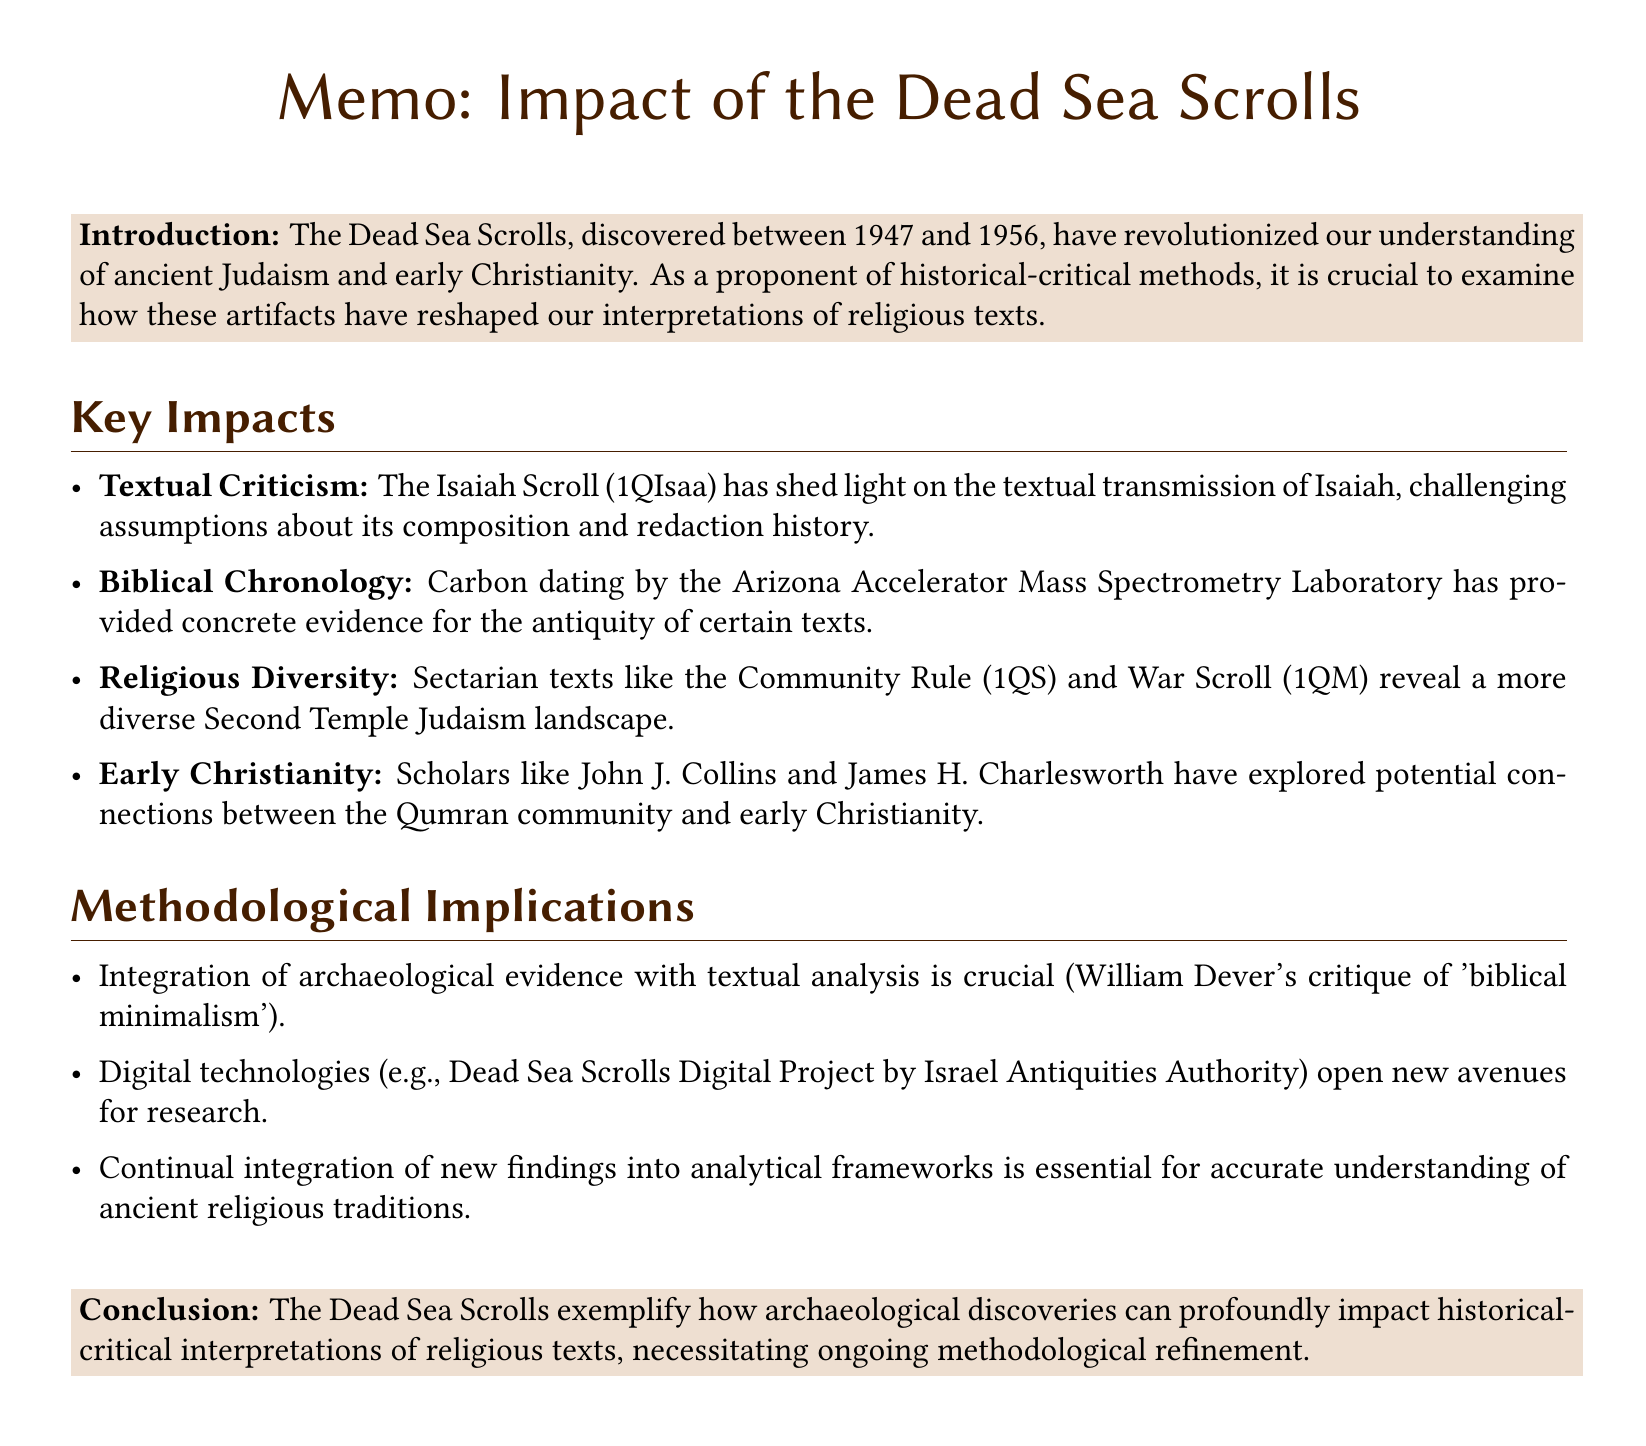What year were the Dead Sea Scrolls discovered? The document states that the Dead Sea Scrolls were discovered between 1947 and 1956.
Answer: 1947-1956 Which scroll is specifically mentioned as shedding light on the textual transmission of Isaiah? The document mentions the Isaiah Scroll (1QIsaa) in relation to textual criticism.
Answer: Isaiah Scroll (1QIsaa) Who are two scholars that have explored connections between the Qumran community and early Christianity? The memo lists John J. Collins and James H. Charlesworth as key figures in this area of research.
Answer: John J. Collins and James H. Charlesworth What archaeological technique was used to date the Dead Sea Scrolls? The document mentions carbon dating, specifically conducted by the Arizona Accelerator Mass Spectrometry Laboratory.
Answer: Carbon dating What title is given to the sectarian text that discusses community rules? The document identifies the Community Rule (1QS) as a sectarian text.
Answer: Community Rule (1QS) What major implication of the Dead Sea Scrolls is highlighted regarding methodologies in religious studies? The memo notes that integration of archaeological evidence with textual analysis is crucial.
Answer: Integration of archaeological evidence with textual analysis What is the name of the digital project associated with the Dead Sea Scrolls for research? The document refers to the Dead Sea Scrolls Digital Project by the Israel Antiquities Authority.
Answer: Dead Sea Scrolls Digital Project What challenge does William Dever's critique address in relation to the Dead Sea Scrolls? The document indicates that his critique addresses the limitations of purely literary approaches in historical-critical studies.
Answer: Limitations of purely literary approaches 